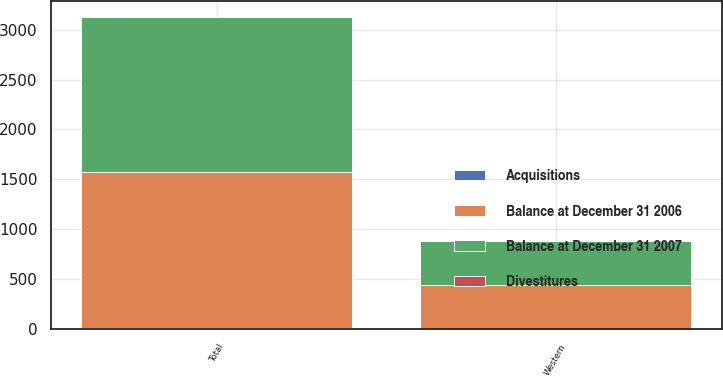Convert chart to OTSL. <chart><loc_0><loc_0><loc_500><loc_500><stacked_bar_chart><ecel><fcel>Western<fcel>Total<nl><fcel>Balance at December 31 2006<fcel>440.3<fcel>1562.9<nl><fcel>Divestitures<fcel>0.1<fcel>1<nl><fcel>Acquisitions<fcel>6.1<fcel>8.2<nl><fcel>Balance at December 31 2007<fcel>434.3<fcel>1555.7<nl></chart> 